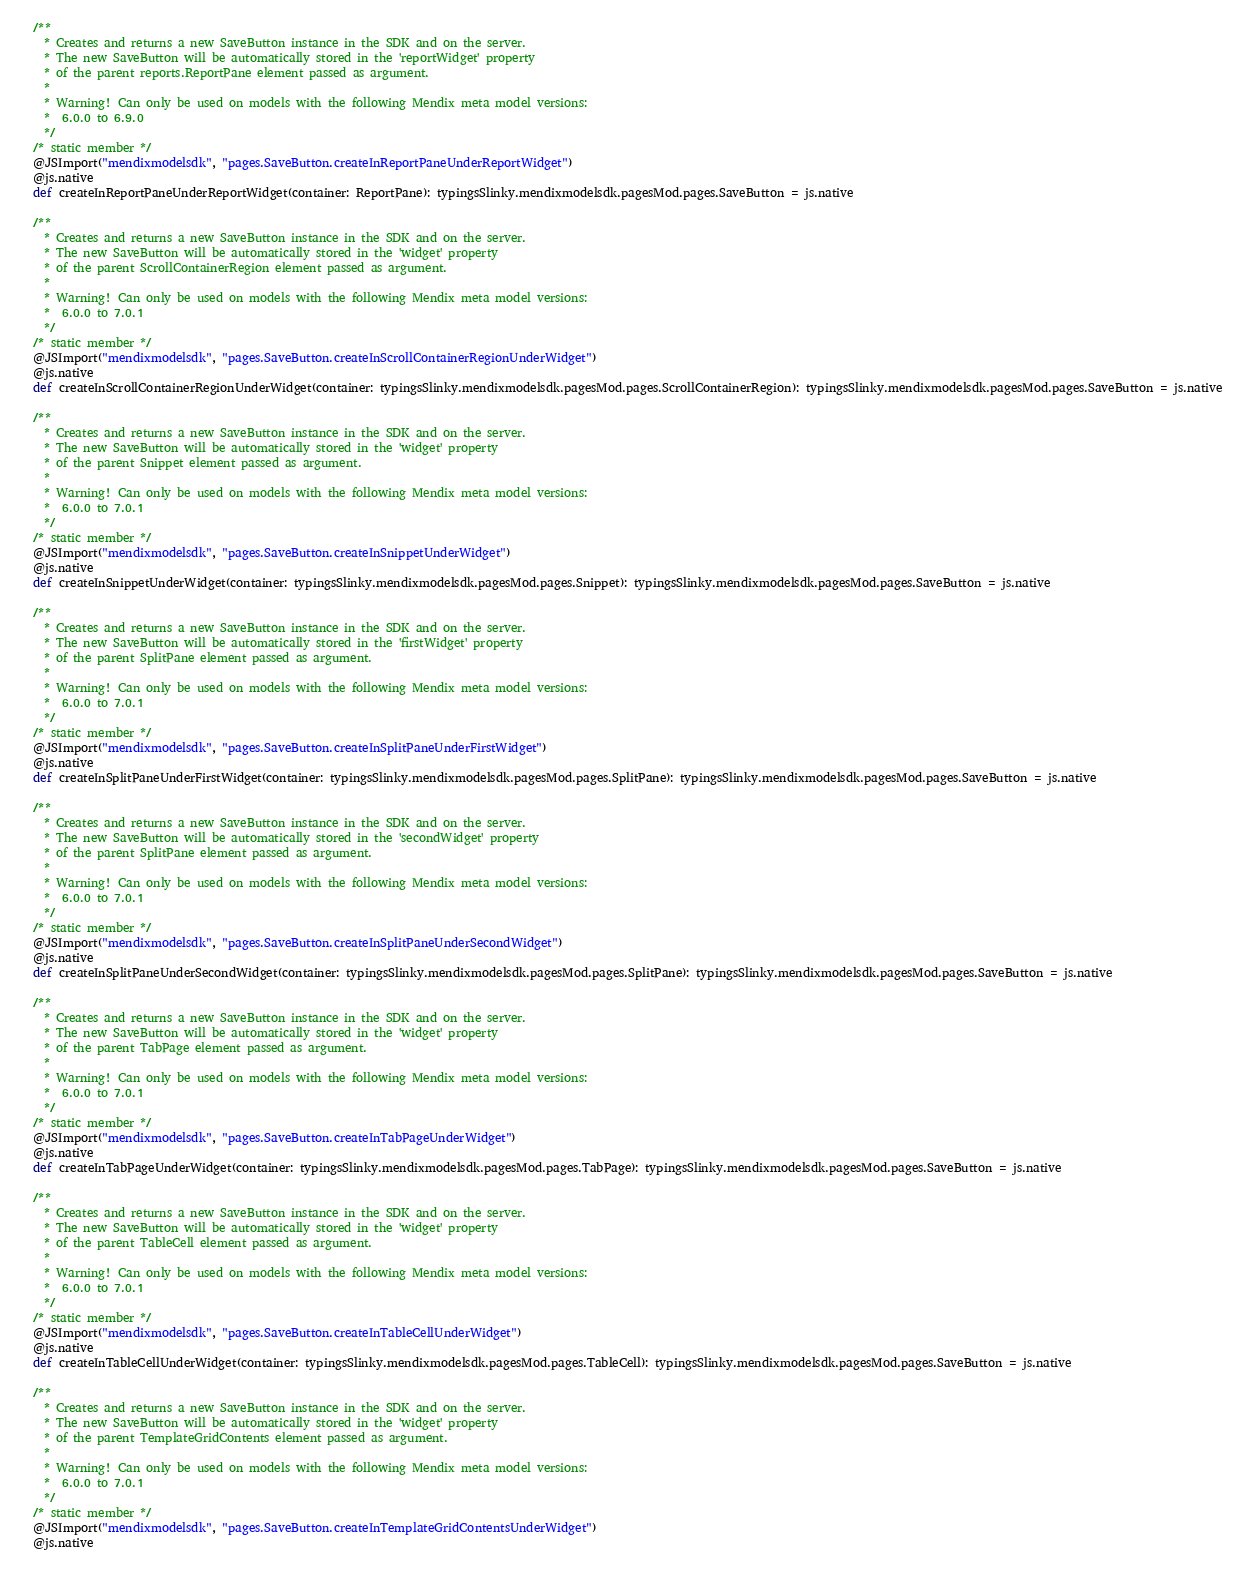<code> <loc_0><loc_0><loc_500><loc_500><_Scala_>  /**
    * Creates and returns a new SaveButton instance in the SDK and on the server.
    * The new SaveButton will be automatically stored in the 'reportWidget' property
    * of the parent reports.ReportPane element passed as argument.
    *
    * Warning! Can only be used on models with the following Mendix meta model versions:
    *  6.0.0 to 6.9.0
    */
  /* static member */
  @JSImport("mendixmodelsdk", "pages.SaveButton.createInReportPaneUnderReportWidget")
  @js.native
  def createInReportPaneUnderReportWidget(container: ReportPane): typingsSlinky.mendixmodelsdk.pagesMod.pages.SaveButton = js.native
  
  /**
    * Creates and returns a new SaveButton instance in the SDK and on the server.
    * The new SaveButton will be automatically stored in the 'widget' property
    * of the parent ScrollContainerRegion element passed as argument.
    *
    * Warning! Can only be used on models with the following Mendix meta model versions:
    *  6.0.0 to 7.0.1
    */
  /* static member */
  @JSImport("mendixmodelsdk", "pages.SaveButton.createInScrollContainerRegionUnderWidget")
  @js.native
  def createInScrollContainerRegionUnderWidget(container: typingsSlinky.mendixmodelsdk.pagesMod.pages.ScrollContainerRegion): typingsSlinky.mendixmodelsdk.pagesMod.pages.SaveButton = js.native
  
  /**
    * Creates and returns a new SaveButton instance in the SDK and on the server.
    * The new SaveButton will be automatically stored in the 'widget' property
    * of the parent Snippet element passed as argument.
    *
    * Warning! Can only be used on models with the following Mendix meta model versions:
    *  6.0.0 to 7.0.1
    */
  /* static member */
  @JSImport("mendixmodelsdk", "pages.SaveButton.createInSnippetUnderWidget")
  @js.native
  def createInSnippetUnderWidget(container: typingsSlinky.mendixmodelsdk.pagesMod.pages.Snippet): typingsSlinky.mendixmodelsdk.pagesMod.pages.SaveButton = js.native
  
  /**
    * Creates and returns a new SaveButton instance in the SDK and on the server.
    * The new SaveButton will be automatically stored in the 'firstWidget' property
    * of the parent SplitPane element passed as argument.
    *
    * Warning! Can only be used on models with the following Mendix meta model versions:
    *  6.0.0 to 7.0.1
    */
  /* static member */
  @JSImport("mendixmodelsdk", "pages.SaveButton.createInSplitPaneUnderFirstWidget")
  @js.native
  def createInSplitPaneUnderFirstWidget(container: typingsSlinky.mendixmodelsdk.pagesMod.pages.SplitPane): typingsSlinky.mendixmodelsdk.pagesMod.pages.SaveButton = js.native
  
  /**
    * Creates and returns a new SaveButton instance in the SDK and on the server.
    * The new SaveButton will be automatically stored in the 'secondWidget' property
    * of the parent SplitPane element passed as argument.
    *
    * Warning! Can only be used on models with the following Mendix meta model versions:
    *  6.0.0 to 7.0.1
    */
  /* static member */
  @JSImport("mendixmodelsdk", "pages.SaveButton.createInSplitPaneUnderSecondWidget")
  @js.native
  def createInSplitPaneUnderSecondWidget(container: typingsSlinky.mendixmodelsdk.pagesMod.pages.SplitPane): typingsSlinky.mendixmodelsdk.pagesMod.pages.SaveButton = js.native
  
  /**
    * Creates and returns a new SaveButton instance in the SDK and on the server.
    * The new SaveButton will be automatically stored in the 'widget' property
    * of the parent TabPage element passed as argument.
    *
    * Warning! Can only be used on models with the following Mendix meta model versions:
    *  6.0.0 to 7.0.1
    */
  /* static member */
  @JSImport("mendixmodelsdk", "pages.SaveButton.createInTabPageUnderWidget")
  @js.native
  def createInTabPageUnderWidget(container: typingsSlinky.mendixmodelsdk.pagesMod.pages.TabPage): typingsSlinky.mendixmodelsdk.pagesMod.pages.SaveButton = js.native
  
  /**
    * Creates and returns a new SaveButton instance in the SDK and on the server.
    * The new SaveButton will be automatically stored in the 'widget' property
    * of the parent TableCell element passed as argument.
    *
    * Warning! Can only be used on models with the following Mendix meta model versions:
    *  6.0.0 to 7.0.1
    */
  /* static member */
  @JSImport("mendixmodelsdk", "pages.SaveButton.createInTableCellUnderWidget")
  @js.native
  def createInTableCellUnderWidget(container: typingsSlinky.mendixmodelsdk.pagesMod.pages.TableCell): typingsSlinky.mendixmodelsdk.pagesMod.pages.SaveButton = js.native
  
  /**
    * Creates and returns a new SaveButton instance in the SDK and on the server.
    * The new SaveButton will be automatically stored in the 'widget' property
    * of the parent TemplateGridContents element passed as argument.
    *
    * Warning! Can only be used on models with the following Mendix meta model versions:
    *  6.0.0 to 7.0.1
    */
  /* static member */
  @JSImport("mendixmodelsdk", "pages.SaveButton.createInTemplateGridContentsUnderWidget")
  @js.native</code> 